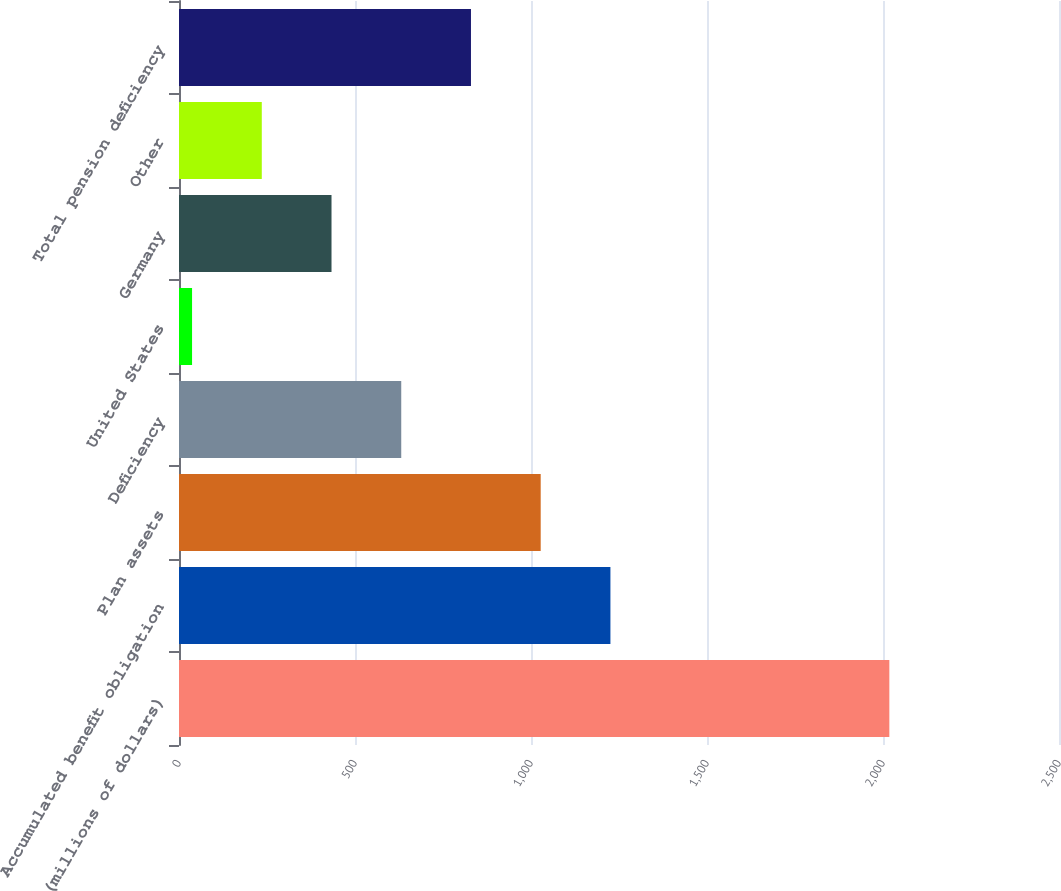<chart> <loc_0><loc_0><loc_500><loc_500><bar_chart><fcel>(millions of dollars)<fcel>Accumulated benefit obligation<fcel>Plan assets<fcel>Deficiency<fcel>United States<fcel>Germany<fcel>Other<fcel>Total pension deficiency<nl><fcel>2018<fcel>1225.64<fcel>1027.55<fcel>631.37<fcel>37.1<fcel>433.28<fcel>235.19<fcel>829.46<nl></chart> 